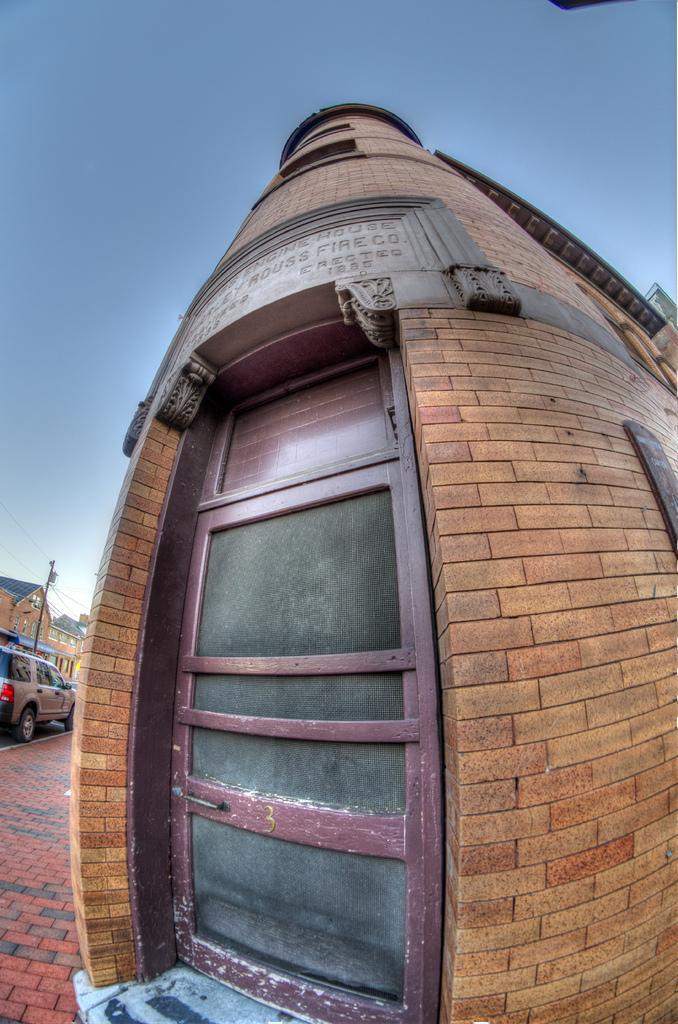Can you describe this image briefly? In this image we can see the building with the door and also the text. We can also see the path, vehicle, electrical pole with wires and also the houses on the left. In the background we can see the sky. 